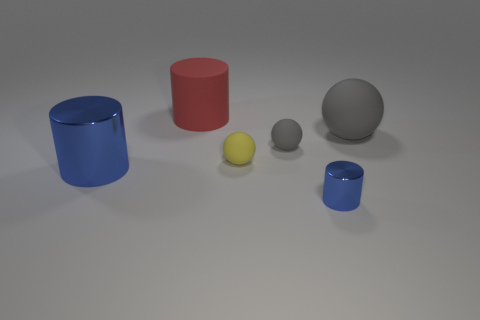There is another cylinder that is the same size as the red cylinder; what material is it?
Your answer should be very brief. Metal. The small gray object has what shape?
Offer a very short reply. Sphere. How many red things are either metallic things or matte cylinders?
Provide a succinct answer. 1. What size is the yellow ball that is the same material as the red cylinder?
Your answer should be compact. Small. Does the cylinder behind the large ball have the same material as the blue cylinder to the left of the small yellow ball?
Provide a short and direct response. No. How many balls are big blue things or small purple objects?
Ensure brevity in your answer.  0. How many blue cylinders are in front of the metallic cylinder behind the blue metallic object right of the big red thing?
Your answer should be compact. 1. What is the material of the yellow thing that is the same shape as the big gray object?
Offer a terse response. Rubber. Is there anything else that has the same material as the red thing?
Make the answer very short. Yes. There is a matte object behind the big gray matte thing; what color is it?
Provide a succinct answer. Red. 